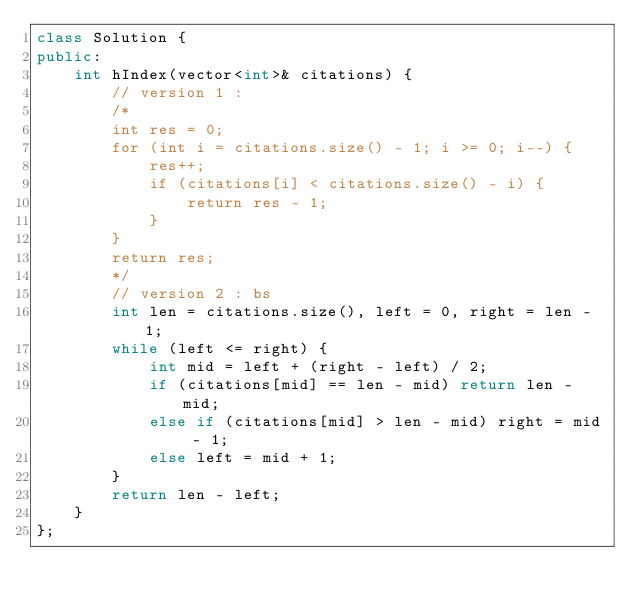Convert code to text. <code><loc_0><loc_0><loc_500><loc_500><_C++_>class Solution {
public:
    int hIndex(vector<int>& citations) {
        // version 1 :
        /*
        int res = 0;
        for (int i = citations.size() - 1; i >= 0; i--) {
            res++;
            if (citations[i] < citations.size() - i) {
                return res - 1;
            } 
        }
        return res;
        */
        // version 2 : bs
        int len = citations.size(), left = 0, right = len - 1;
        while (left <= right) {
            int mid = left + (right - left) / 2;
            if (citations[mid] == len - mid) return len - mid;
            else if (citations[mid] > len - mid) right = mid - 1;
            else left = mid + 1;
        }
        return len - left;
    }
};</code> 